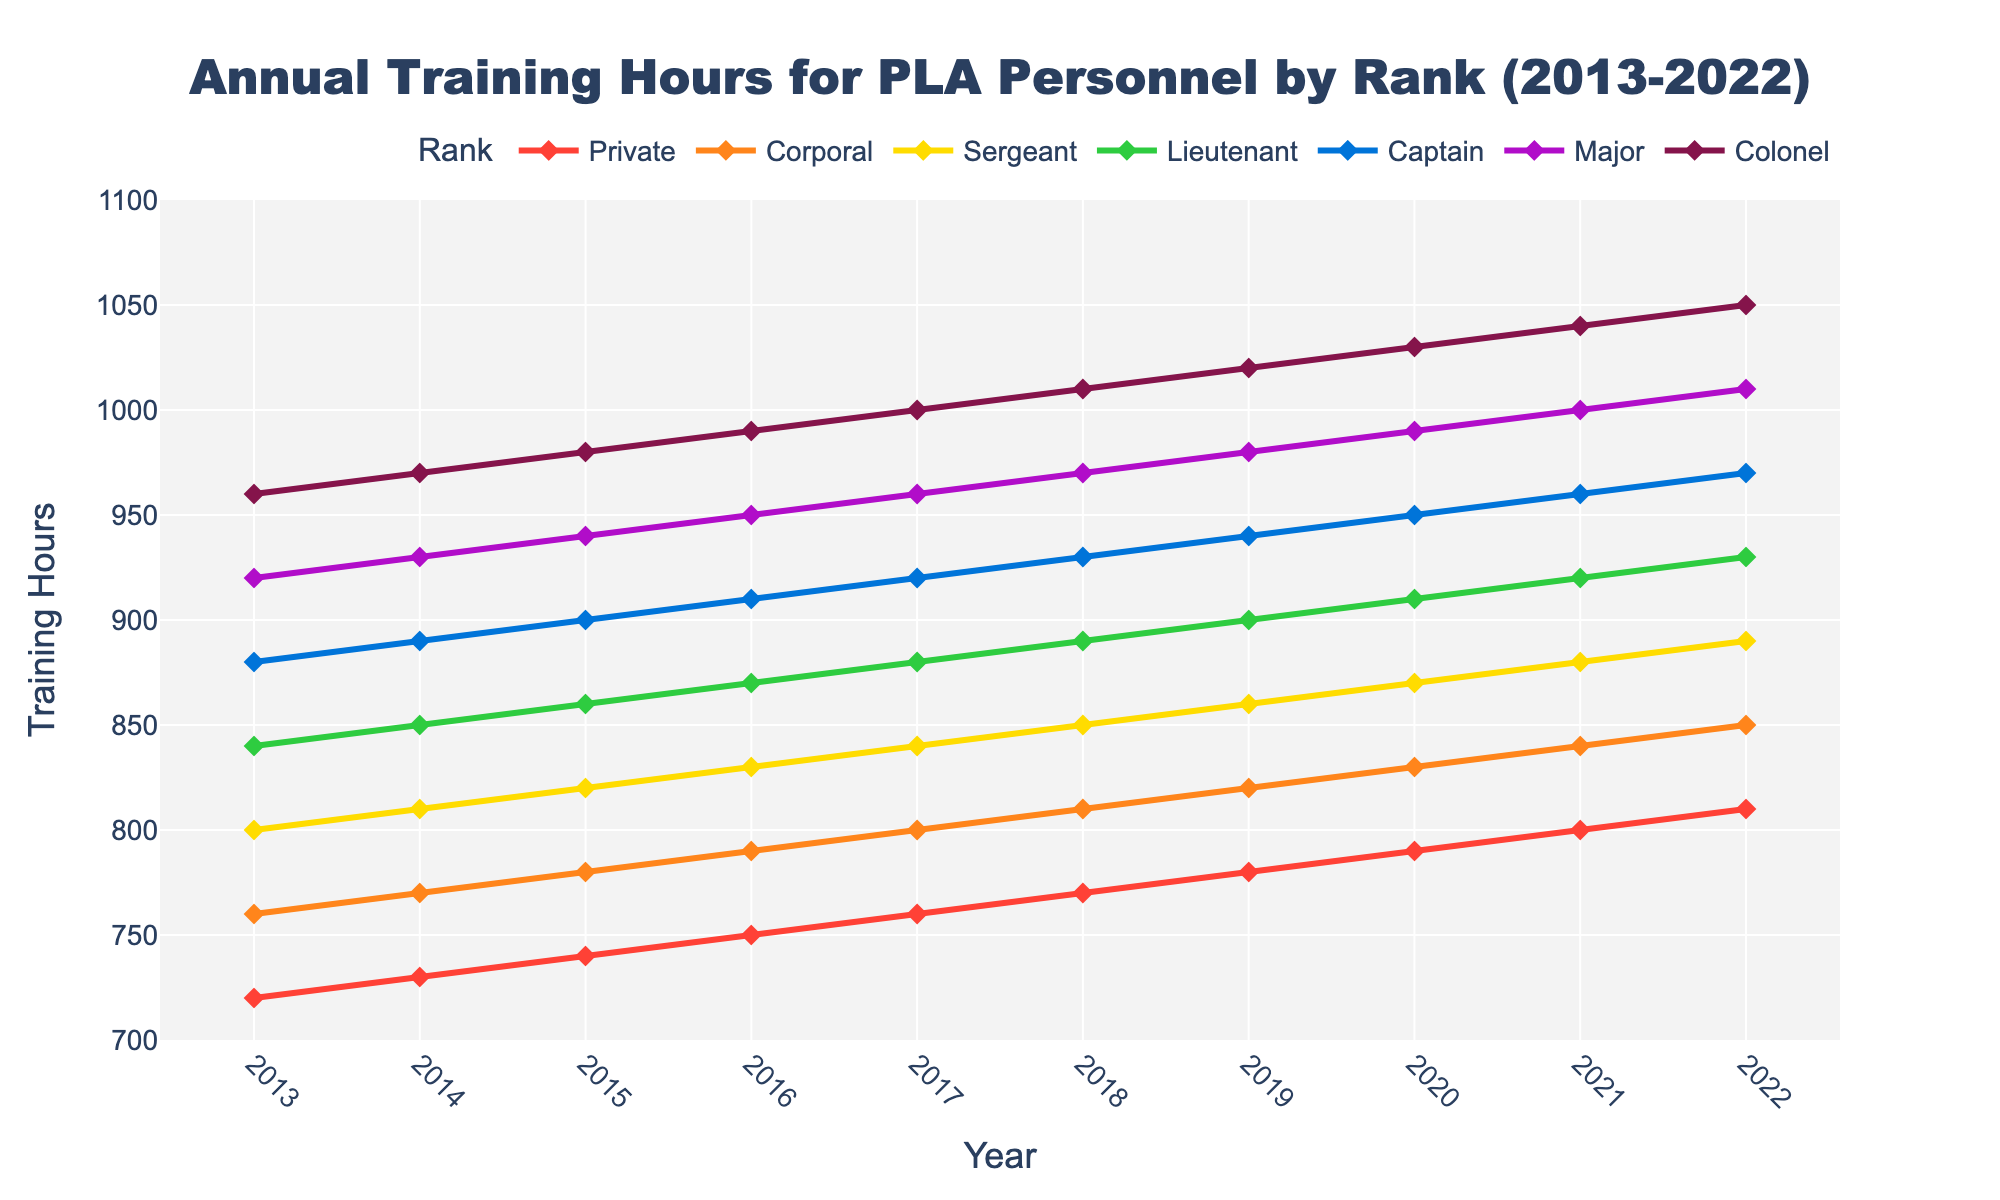What's the total increase in training hours for a Private from 2013 to 2022? To determine the total increase, look at the training hours for a Private in 2013 and 2022. In 2013, it was 720 hours, and in 2022, it was 810 hours. The increase is 810 - 720.
Answer: 90 hours Which rank had the highest training hours in 2018? In 2018, compare the training hours across all ranks. The Colonel had 1010 hours, which is the highest among all ranks.
Answer: Colonel Did the training hours for a Corporal ever decrease over the decade? Check the training hours for a Corporal from 2013 to 2022. Each year, training hours either increase or remain the same; there are no decreases observed.
Answer: No By how much did the training hours for a Major increase from 2017 to 2020? In 2017, a Major had 960 training hours. In 2020, it became 990 hours. The increase is 990 - 960.
Answer: 30 hours Which rank shows the steepest slope in training hours increase from 2019 to 2021? To find the steepest slope, compare the increases from 2019 to 2021 for each rank. Colonel went from 1020 to 1040, an increase of 20. Major went from 980 to 1000, also an increase of 20. Both are steepest increases among all ranks.
Answer: Colonel and Major What's the average training hours for a Sergeant over the decade? Add up the training hours for a Sergeant from 2013 to 2022 (800 + 810 + 820 + 830 + 840 + 850 + 860 + 870 + 880 + 890) and then divide by 10.
Answer: 845 hours Which rank consistently had the least training hours throughout the decade? Observe the trend lines for all ranks from 2013 to 2022. The Private consistently shows the least training hours every year.
Answer: Private Compare the difference in training hours between a Captain and a Lieutenant in 2021. Look at the training hours for a Captain (960) and a Lieutenant (920) in 2021. The difference is 960 - 920.
Answer: 40 hours What is the range of training hours for Captains over the decade? Identify the maximum and minimum training hours for Captains from 2013 to 2022. The maximum is 970 hours in 2022, and the minimum is 880 hours in 2013. The range is 970 - 880.
Answer: 90 hours By what percentage did the training hours for a Colonel increase from 2013 to 2022? First, calculate the increase in training hours (1050 - 960). Then, divide this increase by the initial value in 2013 (960) and multiply by 100 to get the percentage. The percentage increase is (90 / 960) * 100.
Answer: 9.38% 